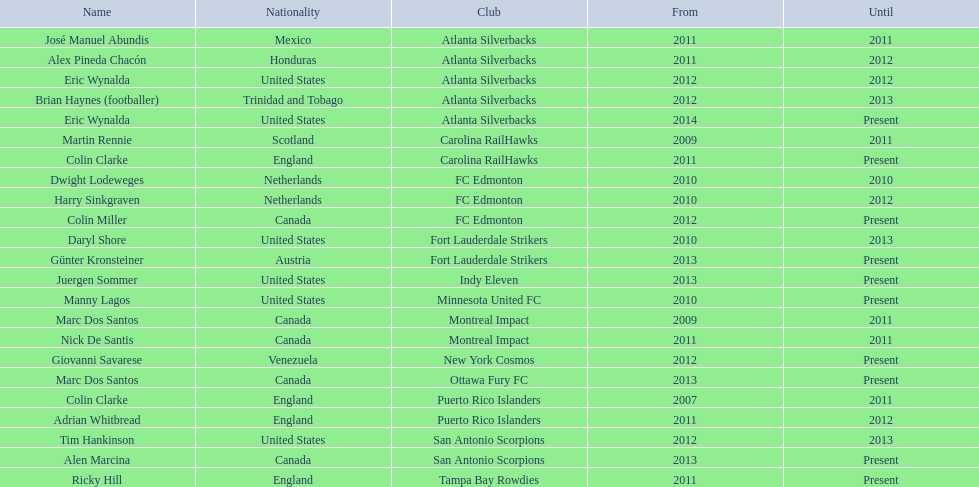Marc dos santos started as coach the same year as what other coach? Martin Rennie. 